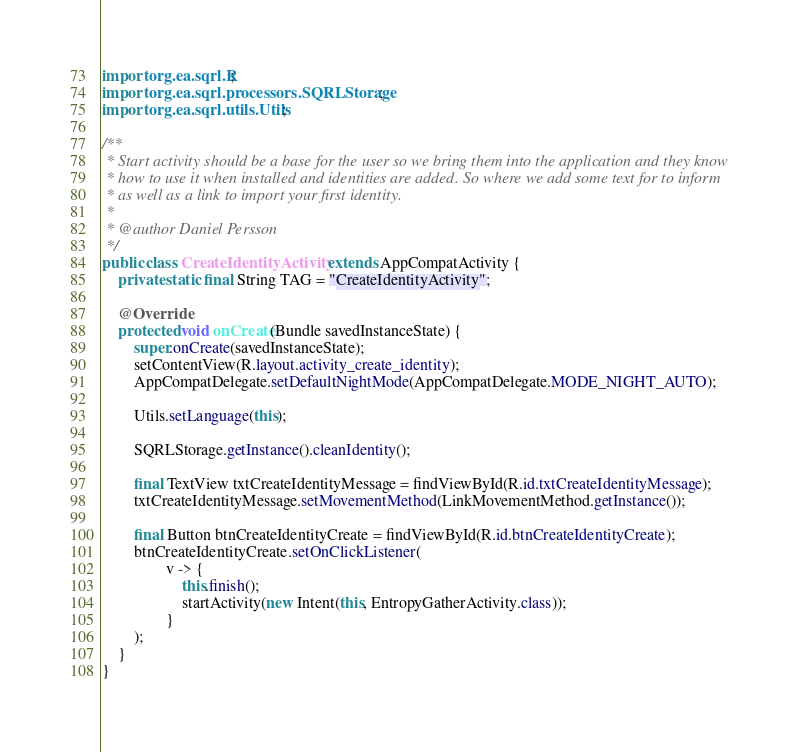<code> <loc_0><loc_0><loc_500><loc_500><_Java_>import org.ea.sqrl.R;
import org.ea.sqrl.processors.SQRLStorage;
import org.ea.sqrl.utils.Utils;

/**
 * Start activity should be a base for the user so we bring them into the application and they know
 * how to use it when installed and identities are added. So where we add some text for to inform
 * as well as a link to import your first identity.
 *
 * @author Daniel Persson
 */
public class CreateIdentityActivity extends AppCompatActivity {
    private static final String TAG = "CreateIdentityActivity";

    @Override
    protected void onCreate(Bundle savedInstanceState) {
        super.onCreate(savedInstanceState);
        setContentView(R.layout.activity_create_identity);
        AppCompatDelegate.setDefaultNightMode(AppCompatDelegate.MODE_NIGHT_AUTO);

        Utils.setLanguage(this);

        SQRLStorage.getInstance().cleanIdentity();

        final TextView txtCreateIdentityMessage = findViewById(R.id.txtCreateIdentityMessage);
        txtCreateIdentityMessage.setMovementMethod(LinkMovementMethod.getInstance());

        final Button btnCreateIdentityCreate = findViewById(R.id.btnCreateIdentityCreate);
        btnCreateIdentityCreate.setOnClickListener(
                v -> {
                    this.finish();
                    startActivity(new Intent(this, EntropyGatherActivity.class));
                }
        );
    }
}
</code> 